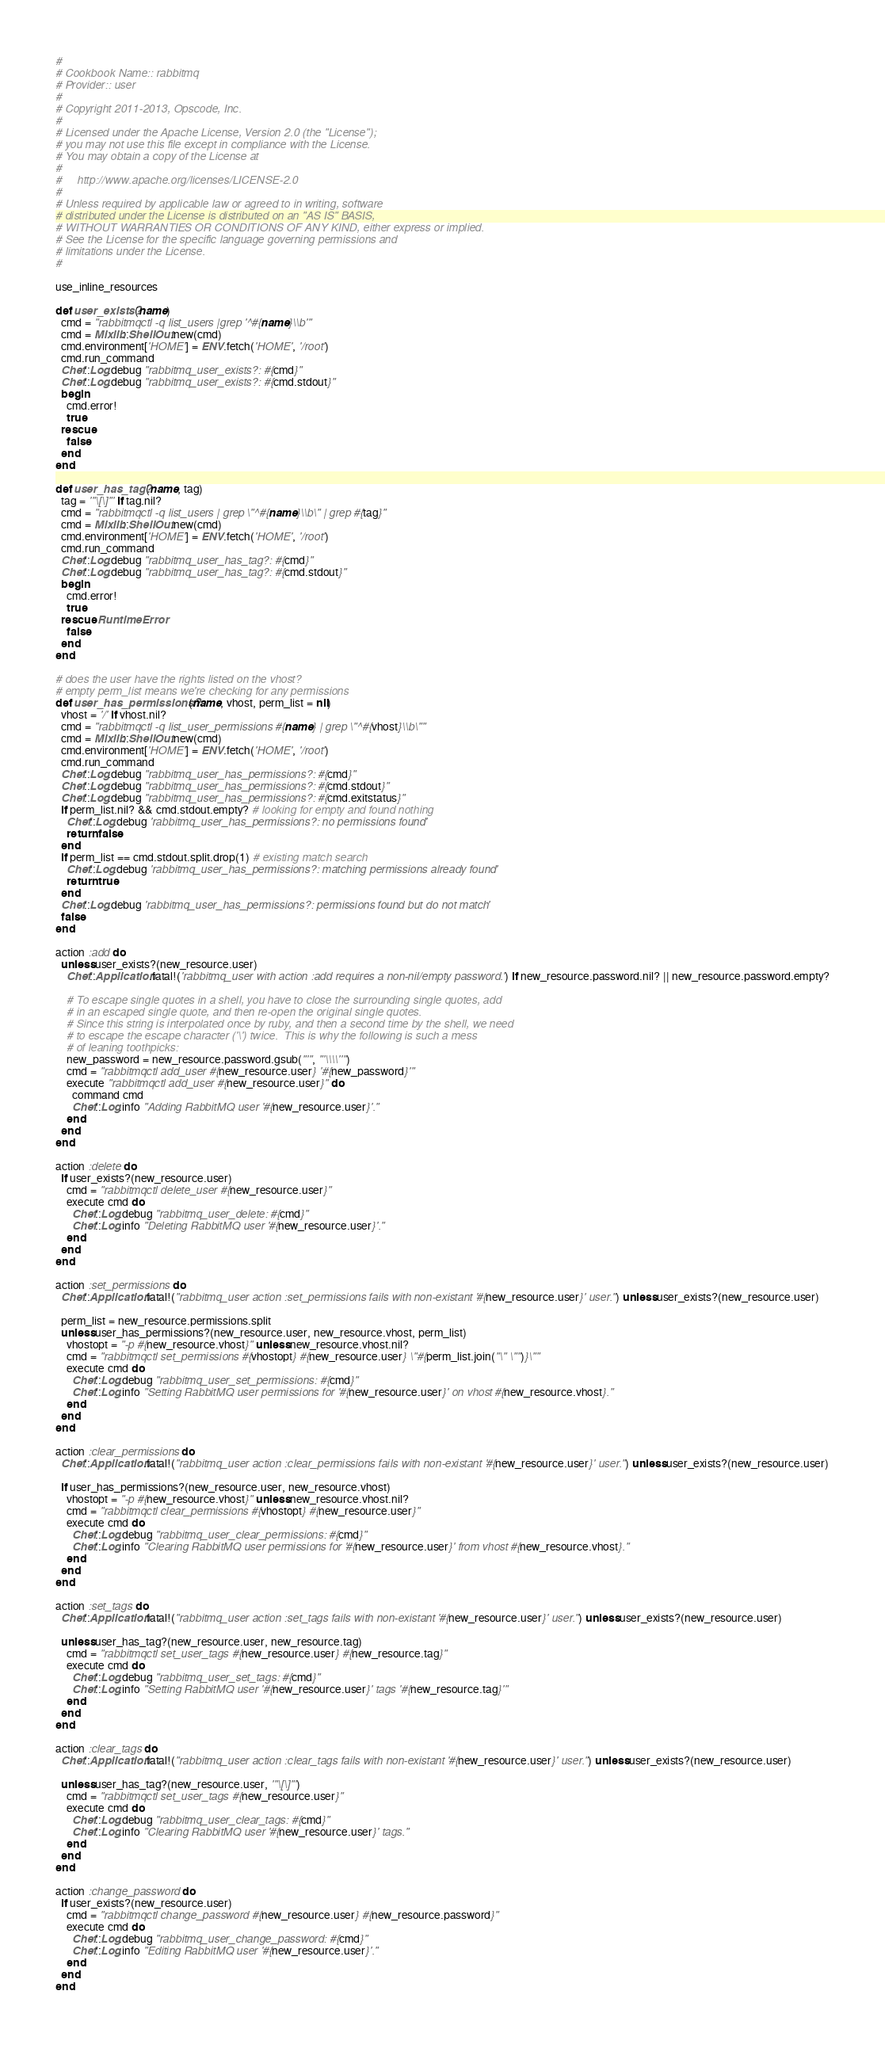Convert code to text. <code><loc_0><loc_0><loc_500><loc_500><_Ruby_>#
# Cookbook Name:: rabbitmq
# Provider:: user
#
# Copyright 2011-2013, Opscode, Inc.
#
# Licensed under the Apache License, Version 2.0 (the "License");
# you may not use this file except in compliance with the License.
# You may obtain a copy of the License at
#
#     http://www.apache.org/licenses/LICENSE-2.0
#
# Unless required by applicable law or agreed to in writing, software
# distributed under the License is distributed on an "AS IS" BASIS,
# WITHOUT WARRANTIES OR CONDITIONS OF ANY KIND, either express or implied.
# See the License for the specific language governing permissions and
# limitations under the License.
#

use_inline_resources

def user_exists?(name)
  cmd = "rabbitmqctl -q list_users |grep '^#{name}\\b'"
  cmd = Mixlib::ShellOut.new(cmd)
  cmd.environment['HOME'] = ENV.fetch('HOME', '/root')
  cmd.run_command
  Chef::Log.debug "rabbitmq_user_exists?: #{cmd}"
  Chef::Log.debug "rabbitmq_user_exists?: #{cmd.stdout}"
  begin
    cmd.error!
    true
  rescue
    false
  end
end

def user_has_tag?(name, tag)
  tag = '"\[\]"' if tag.nil?
  cmd = "rabbitmqctl -q list_users | grep \"^#{name}\\b\" | grep #{tag}"
  cmd = Mixlib::ShellOut.new(cmd)
  cmd.environment['HOME'] = ENV.fetch('HOME', '/root')
  cmd.run_command
  Chef::Log.debug "rabbitmq_user_has_tag?: #{cmd}"
  Chef::Log.debug "rabbitmq_user_has_tag?: #{cmd.stdout}"
  begin
    cmd.error!
    true
  rescue RuntimeError
    false
  end
end

# does the user have the rights listed on the vhost?
# empty perm_list means we're checking for any permissions
def user_has_permissions?(name, vhost, perm_list = nil)
  vhost = '/' if vhost.nil?
  cmd = "rabbitmqctl -q list_user_permissions #{name} | grep \"^#{vhost}\\b\""
  cmd = Mixlib::ShellOut.new(cmd)
  cmd.environment['HOME'] = ENV.fetch('HOME', '/root')
  cmd.run_command
  Chef::Log.debug "rabbitmq_user_has_permissions?: #{cmd}"
  Chef::Log.debug "rabbitmq_user_has_permissions?: #{cmd.stdout}"
  Chef::Log.debug "rabbitmq_user_has_permissions?: #{cmd.exitstatus}"
  if perm_list.nil? && cmd.stdout.empty? # looking for empty and found nothing
    Chef::Log.debug 'rabbitmq_user_has_permissions?: no permissions found'
    return false
  end
  if perm_list == cmd.stdout.split.drop(1) # existing match search
    Chef::Log.debug 'rabbitmq_user_has_permissions?: matching permissions already found'
    return true
  end
  Chef::Log.debug 'rabbitmq_user_has_permissions?: permissions found but do not match'
  false
end

action :add do
  unless user_exists?(new_resource.user)
    Chef::Application.fatal!('rabbitmq_user with action :add requires a non-nil/empty password.') if new_resource.password.nil? || new_resource.password.empty?

    # To escape single quotes in a shell, you have to close the surrounding single quotes, add
    # in an escaped single quote, and then re-open the original single quotes.
    # Since this string is interpolated once by ruby, and then a second time by the shell, we need
    # to escape the escape character ('\') twice.  This is why the following is such a mess
    # of leaning toothpicks:
    new_password = new_resource.password.gsub("'", "'\\\\''")
    cmd = "rabbitmqctl add_user #{new_resource.user} '#{new_password}'"
    execute "rabbitmqctl add_user #{new_resource.user}" do
      command cmd
      Chef::Log.info "Adding RabbitMQ user '#{new_resource.user}'."
    end
  end
end

action :delete do
  if user_exists?(new_resource.user)
    cmd = "rabbitmqctl delete_user #{new_resource.user}"
    execute cmd do
      Chef::Log.debug "rabbitmq_user_delete: #{cmd}"
      Chef::Log.info "Deleting RabbitMQ user '#{new_resource.user}'."
    end
  end
end

action :set_permissions do
  Chef::Application.fatal!("rabbitmq_user action :set_permissions fails with non-existant '#{new_resource.user}' user.") unless user_exists?(new_resource.user)

  perm_list = new_resource.permissions.split
  unless user_has_permissions?(new_resource.user, new_resource.vhost, perm_list)
    vhostopt = "-p #{new_resource.vhost}" unless new_resource.vhost.nil?
    cmd = "rabbitmqctl set_permissions #{vhostopt} #{new_resource.user} \"#{perm_list.join("\" \"")}\""
    execute cmd do
      Chef::Log.debug "rabbitmq_user_set_permissions: #{cmd}"
      Chef::Log.info "Setting RabbitMQ user permissions for '#{new_resource.user}' on vhost #{new_resource.vhost}."
    end
  end
end

action :clear_permissions do
  Chef::Application.fatal!("rabbitmq_user action :clear_permissions fails with non-existant '#{new_resource.user}' user.") unless user_exists?(new_resource.user)

  if user_has_permissions?(new_resource.user, new_resource.vhost)
    vhostopt = "-p #{new_resource.vhost}" unless new_resource.vhost.nil?
    cmd = "rabbitmqctl clear_permissions #{vhostopt} #{new_resource.user}"
    execute cmd do
      Chef::Log.debug "rabbitmq_user_clear_permissions: #{cmd}"
      Chef::Log.info "Clearing RabbitMQ user permissions for '#{new_resource.user}' from vhost #{new_resource.vhost}."
    end
  end
end

action :set_tags do
  Chef::Application.fatal!("rabbitmq_user action :set_tags fails with non-existant '#{new_resource.user}' user.") unless user_exists?(new_resource.user)

  unless user_has_tag?(new_resource.user, new_resource.tag)
    cmd = "rabbitmqctl set_user_tags #{new_resource.user} #{new_resource.tag}"
    execute cmd do
      Chef::Log.debug "rabbitmq_user_set_tags: #{cmd}"
      Chef::Log.info "Setting RabbitMQ user '#{new_resource.user}' tags '#{new_resource.tag}'"
    end
  end
end

action :clear_tags do
  Chef::Application.fatal!("rabbitmq_user action :clear_tags fails with non-existant '#{new_resource.user}' user.") unless user_exists?(new_resource.user)

  unless user_has_tag?(new_resource.user, '"\[\]"')
    cmd = "rabbitmqctl set_user_tags #{new_resource.user}"
    execute cmd do
      Chef::Log.debug "rabbitmq_user_clear_tags: #{cmd}"
      Chef::Log.info "Clearing RabbitMQ user '#{new_resource.user}' tags."
    end
  end
end

action :change_password do
  if user_exists?(new_resource.user)
    cmd = "rabbitmqctl change_password #{new_resource.user} #{new_resource.password}"
    execute cmd do
      Chef::Log.debug "rabbitmq_user_change_password: #{cmd}"
      Chef::Log.info "Editing RabbitMQ user '#{new_resource.user}'."
    end
  end
end
</code> 